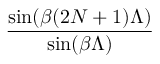Convert formula to latex. <formula><loc_0><loc_0><loc_500><loc_500>\frac { \sin ( \beta ( 2 N + 1 ) \Lambda ) } { \sin ( \beta \Lambda ) }</formula> 